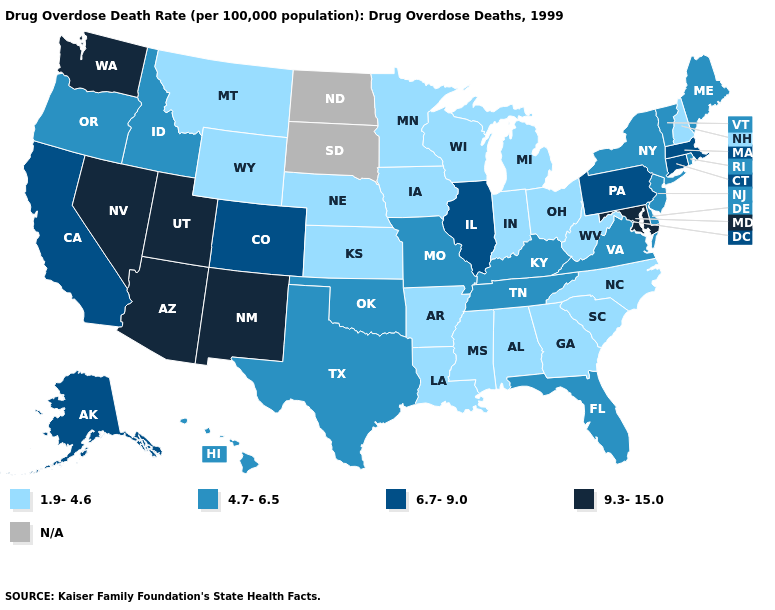Which states have the lowest value in the South?
Short answer required. Alabama, Arkansas, Georgia, Louisiana, Mississippi, North Carolina, South Carolina, West Virginia. Name the states that have a value in the range 1.9-4.6?
Quick response, please. Alabama, Arkansas, Georgia, Indiana, Iowa, Kansas, Louisiana, Michigan, Minnesota, Mississippi, Montana, Nebraska, New Hampshire, North Carolina, Ohio, South Carolina, West Virginia, Wisconsin, Wyoming. Is the legend a continuous bar?
Write a very short answer. No. Which states have the lowest value in the USA?
Short answer required. Alabama, Arkansas, Georgia, Indiana, Iowa, Kansas, Louisiana, Michigan, Minnesota, Mississippi, Montana, Nebraska, New Hampshire, North Carolina, Ohio, South Carolina, West Virginia, Wisconsin, Wyoming. Is the legend a continuous bar?
Keep it brief. No. What is the lowest value in the USA?
Write a very short answer. 1.9-4.6. What is the value of Pennsylvania?
Short answer required. 6.7-9.0. Name the states that have a value in the range 6.7-9.0?
Answer briefly. Alaska, California, Colorado, Connecticut, Illinois, Massachusetts, Pennsylvania. Name the states that have a value in the range N/A?
Quick response, please. North Dakota, South Dakota. What is the lowest value in the USA?
Give a very brief answer. 1.9-4.6. Does Nebraska have the lowest value in the USA?
Concise answer only. Yes. Is the legend a continuous bar?
Quick response, please. No. Does the map have missing data?
Be succinct. Yes. What is the lowest value in the West?
Quick response, please. 1.9-4.6. What is the value of Washington?
Answer briefly. 9.3-15.0. 